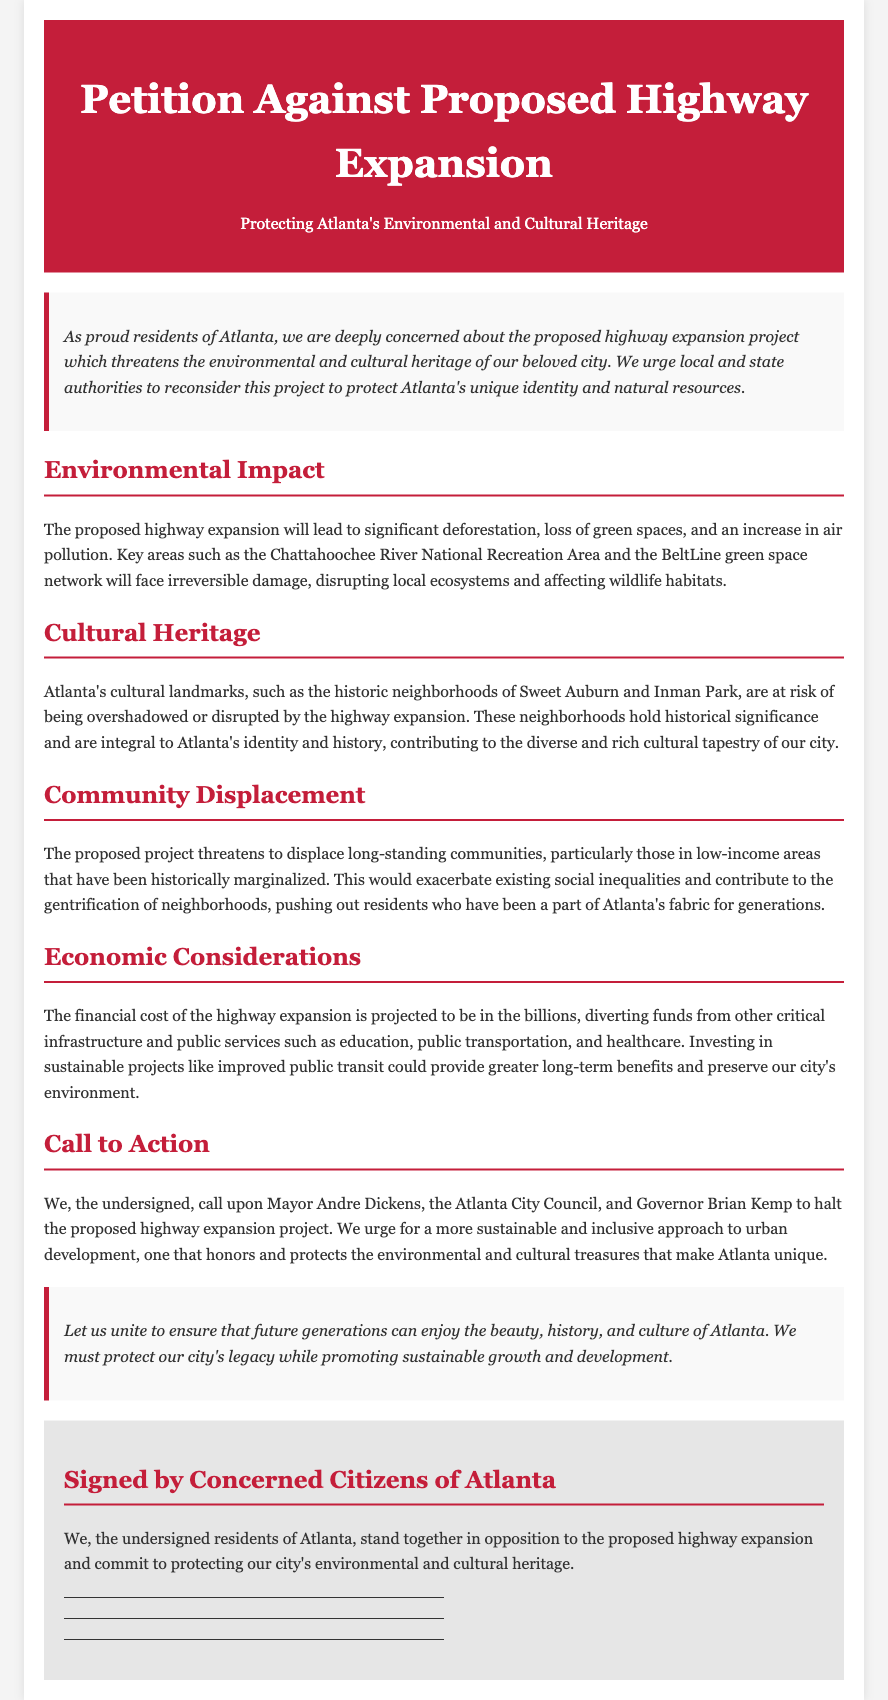What is the title of the petition? The title of the petition is prominently displayed at the top of the document.
Answer: Petition Against Proposed Highway Expansion Who is the petition addressed to? The petition calls upon specific local and state authorities mentioned in the document.
Answer: Mayor Andre Dickens, Atlanta City Council, Governor Brian Kemp What are the key areas at risk due to the proposed highway expansion? The document lists specific locations that will be affected by the expansion project.
Answer: Chattahoochee River National Recreation Area, BeltLine green space network What economic impact does the petition mention? The petition highlights a specific financial consideration regarding the cost of the project.
Answer: Billions What is the call to action stated in the document? The document includes a clear request directed at specific officials.
Answer: Halt the proposed highway expansion project What cultural areas are at risk from the highway expansion? The petition identifies significant neighborhoods that are culturally important to the city.
Answer: Sweet Auburn, Inman Park What is the primary concern regarding community displacement? The document describes the demographic affected by the expansion and its broader social implications.
Answer: Low-income areas What type of development does the petition advocate for? The conclusion reflects the desired approach toward urban planning and development.
Answer: Sustainable and inclusive 